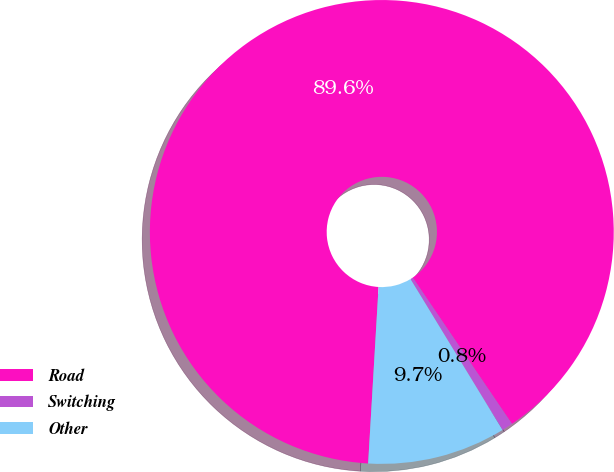<chart> <loc_0><loc_0><loc_500><loc_500><pie_chart><fcel>Road<fcel>Switching<fcel>Other<nl><fcel>89.57%<fcel>0.77%<fcel>9.65%<nl></chart> 